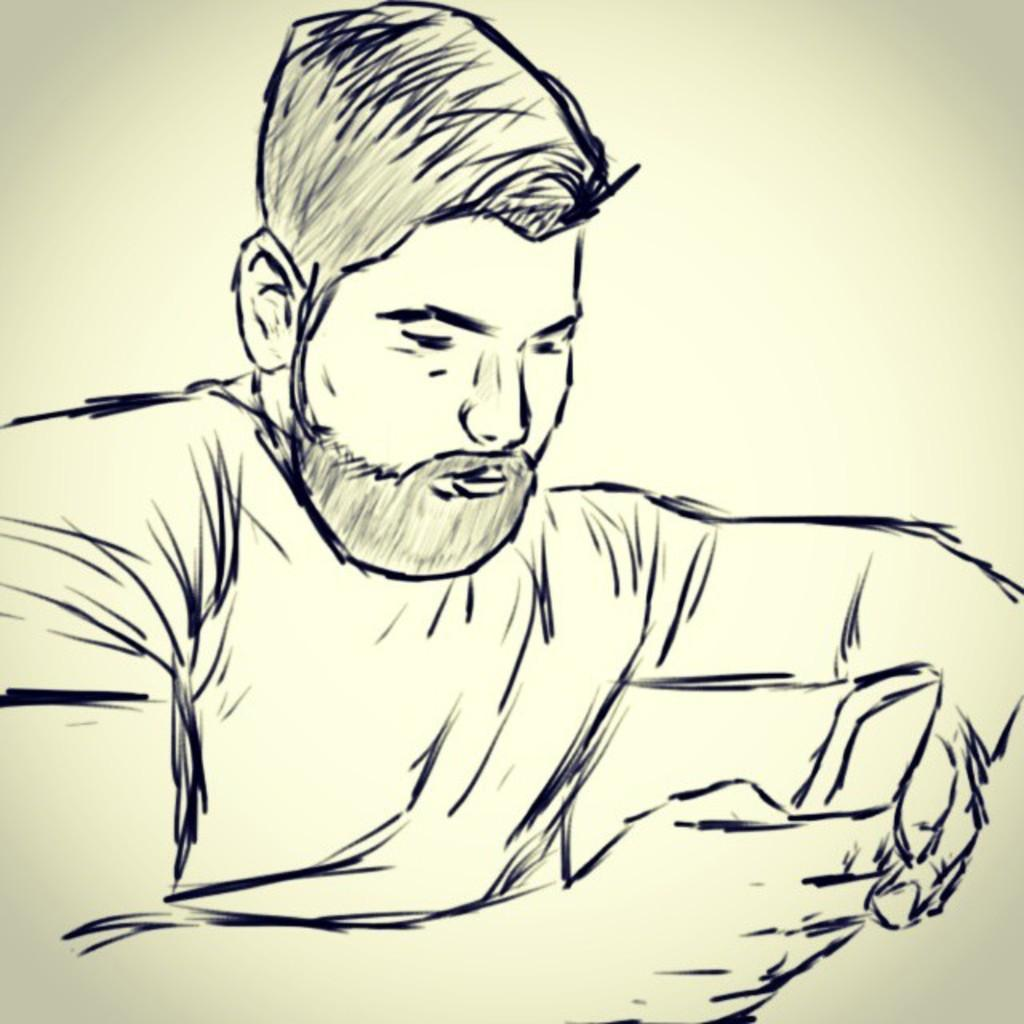What is the main subject of the image? There is an art piece in the image. What color is the background of the image? The background of the image is cream-colored. What type of needle is being used by the parent in the image? There is no needle or parent present in the image; it only features an art piece and a cream-colored background. 